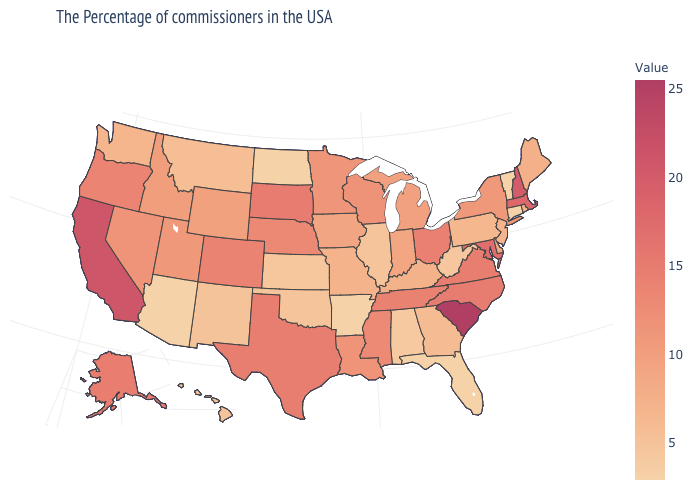Which states have the lowest value in the USA?
Give a very brief answer. Vermont, Connecticut, Florida, Arkansas, North Dakota, Arizona. Does South Carolina have the highest value in the USA?
Concise answer only. Yes. Which states have the lowest value in the Northeast?
Keep it brief. Vermont, Connecticut. Which states hav the highest value in the MidWest?
Keep it brief. South Dakota. Which states have the highest value in the USA?
Write a very short answer. South Carolina. 